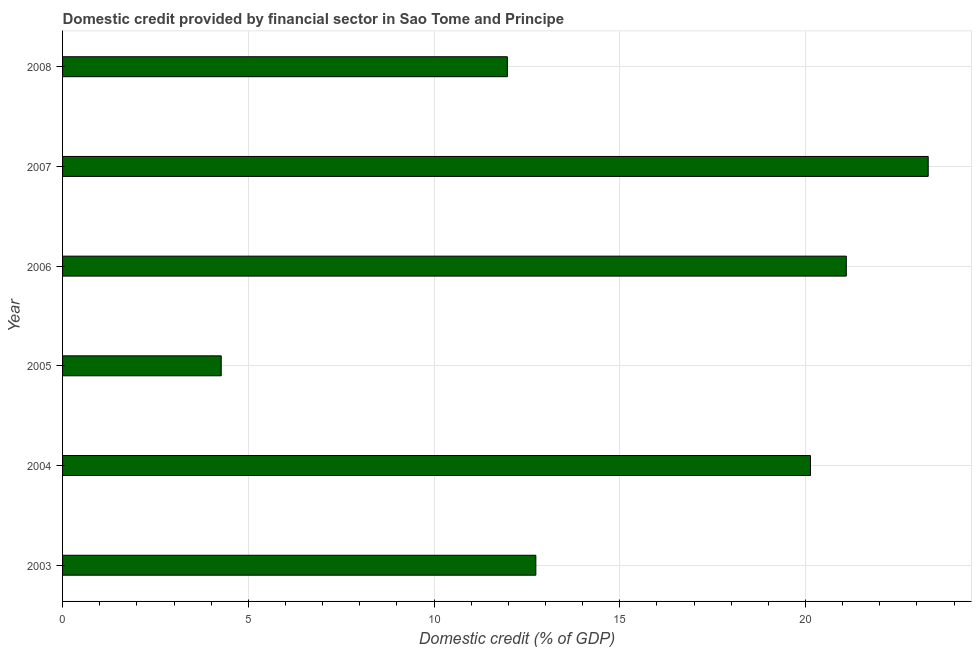Does the graph contain any zero values?
Provide a succinct answer. No. What is the title of the graph?
Your response must be concise. Domestic credit provided by financial sector in Sao Tome and Principe. What is the label or title of the X-axis?
Your response must be concise. Domestic credit (% of GDP). What is the domestic credit provided by financial sector in 2006?
Make the answer very short. 21.1. Across all years, what is the maximum domestic credit provided by financial sector?
Provide a succinct answer. 23.3. Across all years, what is the minimum domestic credit provided by financial sector?
Keep it short and to the point. 4.27. In which year was the domestic credit provided by financial sector maximum?
Keep it short and to the point. 2007. In which year was the domestic credit provided by financial sector minimum?
Give a very brief answer. 2005. What is the sum of the domestic credit provided by financial sector?
Give a very brief answer. 93.52. What is the difference between the domestic credit provided by financial sector in 2003 and 2005?
Offer a very short reply. 8.47. What is the average domestic credit provided by financial sector per year?
Provide a short and direct response. 15.59. What is the median domestic credit provided by financial sector?
Ensure brevity in your answer.  16.44. In how many years, is the domestic credit provided by financial sector greater than 19 %?
Keep it short and to the point. 3. What is the ratio of the domestic credit provided by financial sector in 2003 to that in 2004?
Make the answer very short. 0.63. Is the difference between the domestic credit provided by financial sector in 2003 and 2007 greater than the difference between any two years?
Ensure brevity in your answer.  No. What is the difference between the highest and the second highest domestic credit provided by financial sector?
Offer a very short reply. 2.21. Is the sum of the domestic credit provided by financial sector in 2004 and 2007 greater than the maximum domestic credit provided by financial sector across all years?
Ensure brevity in your answer.  Yes. What is the difference between the highest and the lowest domestic credit provided by financial sector?
Your answer should be compact. 19.03. How many bars are there?
Your response must be concise. 6. What is the Domestic credit (% of GDP) in 2003?
Offer a terse response. 12.74. What is the Domestic credit (% of GDP) of 2004?
Offer a very short reply. 20.13. What is the Domestic credit (% of GDP) in 2005?
Your answer should be very brief. 4.27. What is the Domestic credit (% of GDP) of 2006?
Ensure brevity in your answer.  21.1. What is the Domestic credit (% of GDP) of 2007?
Your answer should be very brief. 23.3. What is the Domestic credit (% of GDP) of 2008?
Your answer should be compact. 11.97. What is the difference between the Domestic credit (% of GDP) in 2003 and 2004?
Offer a terse response. -7.39. What is the difference between the Domestic credit (% of GDP) in 2003 and 2005?
Give a very brief answer. 8.47. What is the difference between the Domestic credit (% of GDP) in 2003 and 2006?
Provide a short and direct response. -8.36. What is the difference between the Domestic credit (% of GDP) in 2003 and 2007?
Make the answer very short. -10.56. What is the difference between the Domestic credit (% of GDP) in 2003 and 2008?
Provide a short and direct response. 0.77. What is the difference between the Domestic credit (% of GDP) in 2004 and 2005?
Offer a terse response. 15.86. What is the difference between the Domestic credit (% of GDP) in 2004 and 2006?
Your answer should be very brief. -0.96. What is the difference between the Domestic credit (% of GDP) in 2004 and 2007?
Provide a succinct answer. -3.17. What is the difference between the Domestic credit (% of GDP) in 2004 and 2008?
Ensure brevity in your answer.  8.16. What is the difference between the Domestic credit (% of GDP) in 2005 and 2006?
Make the answer very short. -16.83. What is the difference between the Domestic credit (% of GDP) in 2005 and 2007?
Give a very brief answer. -19.03. What is the difference between the Domestic credit (% of GDP) in 2005 and 2008?
Provide a succinct answer. -7.7. What is the difference between the Domestic credit (% of GDP) in 2006 and 2007?
Your answer should be very brief. -2.21. What is the difference between the Domestic credit (% of GDP) in 2006 and 2008?
Provide a short and direct response. 9.12. What is the difference between the Domestic credit (% of GDP) in 2007 and 2008?
Your answer should be very brief. 11.33. What is the ratio of the Domestic credit (% of GDP) in 2003 to that in 2004?
Your response must be concise. 0.63. What is the ratio of the Domestic credit (% of GDP) in 2003 to that in 2005?
Your answer should be very brief. 2.98. What is the ratio of the Domestic credit (% of GDP) in 2003 to that in 2006?
Keep it short and to the point. 0.6. What is the ratio of the Domestic credit (% of GDP) in 2003 to that in 2007?
Keep it short and to the point. 0.55. What is the ratio of the Domestic credit (% of GDP) in 2003 to that in 2008?
Offer a very short reply. 1.06. What is the ratio of the Domestic credit (% of GDP) in 2004 to that in 2005?
Your answer should be very brief. 4.71. What is the ratio of the Domestic credit (% of GDP) in 2004 to that in 2006?
Provide a short and direct response. 0.95. What is the ratio of the Domestic credit (% of GDP) in 2004 to that in 2007?
Provide a succinct answer. 0.86. What is the ratio of the Domestic credit (% of GDP) in 2004 to that in 2008?
Ensure brevity in your answer.  1.68. What is the ratio of the Domestic credit (% of GDP) in 2005 to that in 2006?
Your answer should be very brief. 0.2. What is the ratio of the Domestic credit (% of GDP) in 2005 to that in 2007?
Keep it short and to the point. 0.18. What is the ratio of the Domestic credit (% of GDP) in 2005 to that in 2008?
Your answer should be compact. 0.36. What is the ratio of the Domestic credit (% of GDP) in 2006 to that in 2007?
Offer a terse response. 0.91. What is the ratio of the Domestic credit (% of GDP) in 2006 to that in 2008?
Give a very brief answer. 1.76. What is the ratio of the Domestic credit (% of GDP) in 2007 to that in 2008?
Provide a succinct answer. 1.95. 